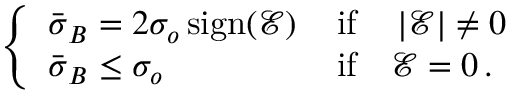<formula> <loc_0><loc_0><loc_500><loc_500>\begin{array} { r } { \left \{ \begin{array} { l l } { \bar { \sigma } _ { B } = 2 \sigma _ { o } \, s i g n { \left ( \mathcal { E } \right ) } \, } & { i f \quad \left | \mathcal { E } \right | \ne 0 } \\ { \bar { \sigma } _ { B } \leq \sigma _ { o } } & { i f \quad \mathcal { E } = 0 \, . } \end{array} } \end{array}</formula> 